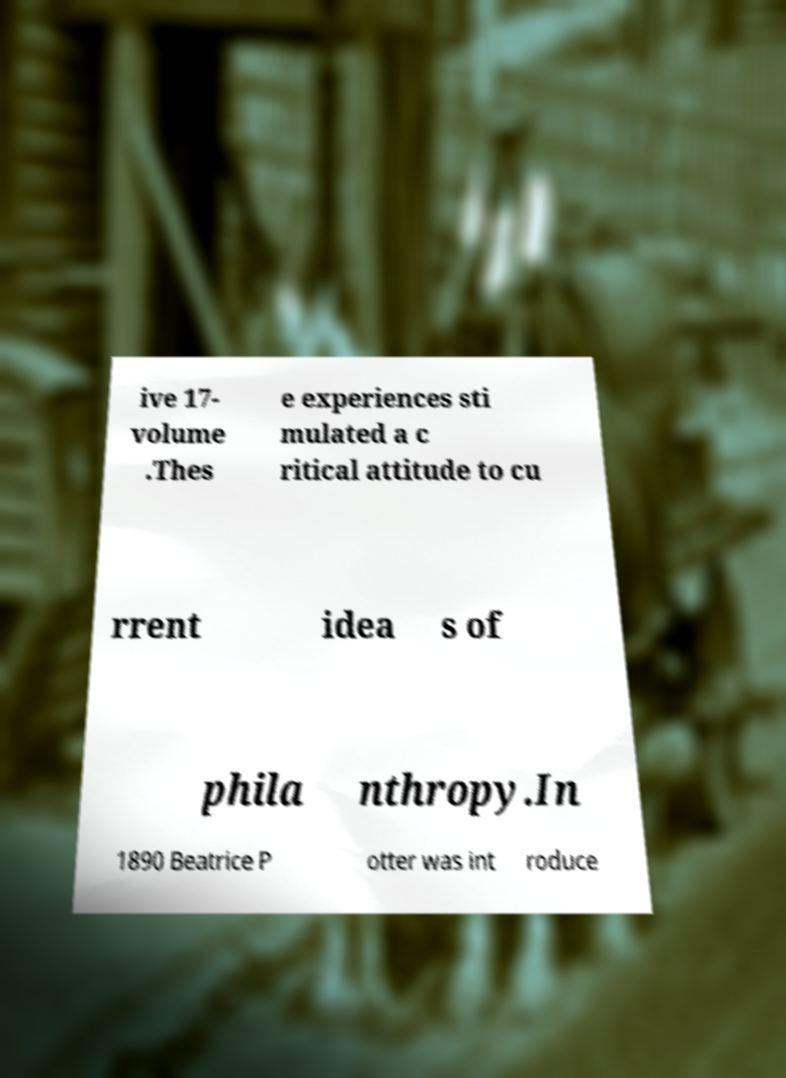Please identify and transcribe the text found in this image. ive 17- volume .Thes e experiences sti mulated a c ritical attitude to cu rrent idea s of phila nthropy.In 1890 Beatrice P otter was int roduce 